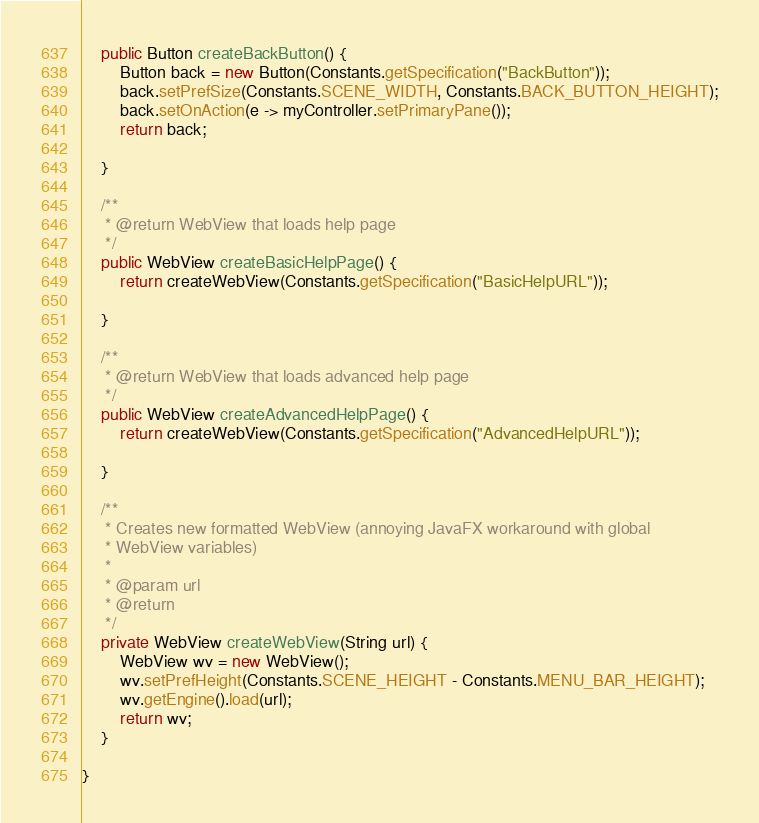Convert code to text. <code><loc_0><loc_0><loc_500><loc_500><_Java_>
	public Button createBackButton() {
		Button back = new Button(Constants.getSpecification("BackButton"));
		back.setPrefSize(Constants.SCENE_WIDTH, Constants.BACK_BUTTON_HEIGHT);
		back.setOnAction(e -> myController.setPrimaryPane());
		return back;

	}

	/**
	 * @return WebView that loads help page
	 */
	public WebView createBasicHelpPage() {
		return createWebView(Constants.getSpecification("BasicHelpURL"));

	}

	/**
	 * @return WebView that loads advanced help page
	 */
	public WebView createAdvancedHelpPage() {
		return createWebView(Constants.getSpecification("AdvancedHelpURL"));

	}

	/**
	 * Creates new formatted WebView (annoying JavaFX workaround with global
	 * WebView variables)
	 * 
	 * @param url
	 * @return
	 */
	private WebView createWebView(String url) {
		WebView wv = new WebView();
		wv.setPrefHeight(Constants.SCENE_HEIGHT - Constants.MENU_BAR_HEIGHT);
		wv.getEngine().load(url);
		return wv;
	}

}
</code> 